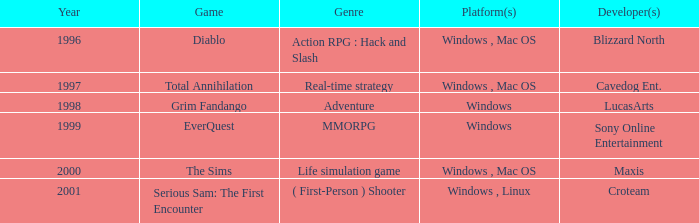What game in the genre of adventure, has a windows platform and its year is after 1997? Grim Fandango. 